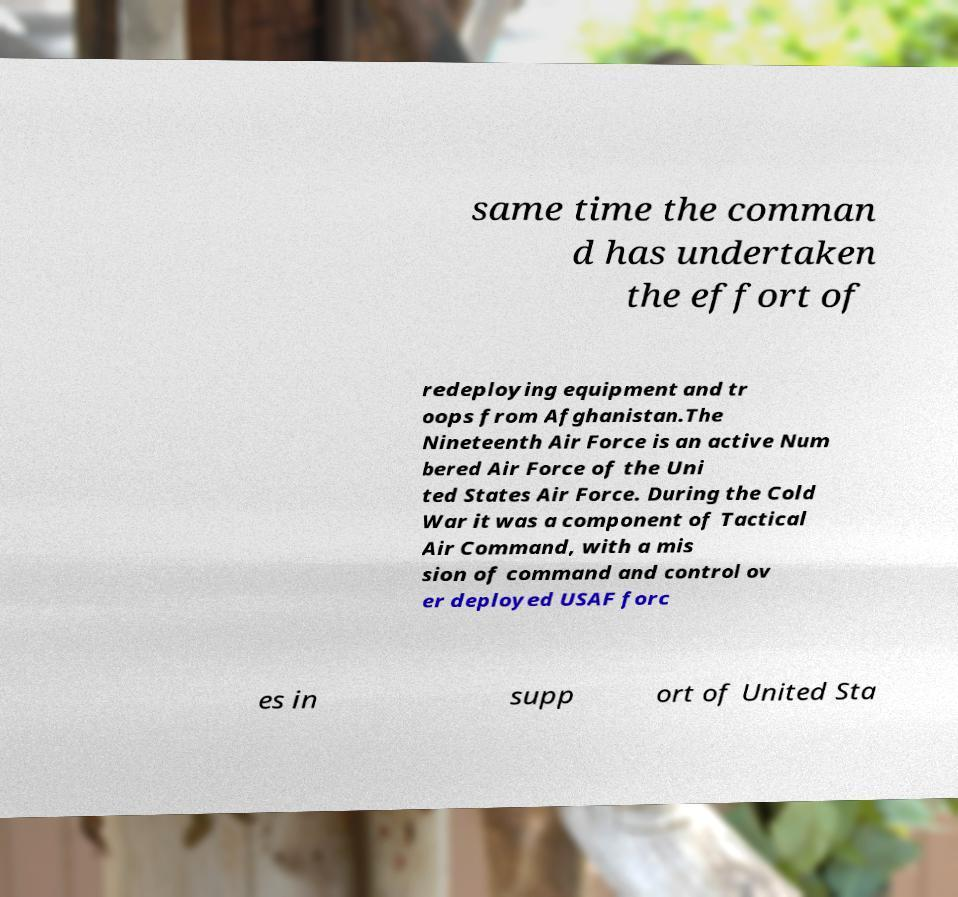What messages or text are displayed in this image? I need them in a readable, typed format. same time the comman d has undertaken the effort of redeploying equipment and tr oops from Afghanistan.The Nineteenth Air Force is an active Num bered Air Force of the Uni ted States Air Force. During the Cold War it was a component of Tactical Air Command, with a mis sion of command and control ov er deployed USAF forc es in supp ort of United Sta 